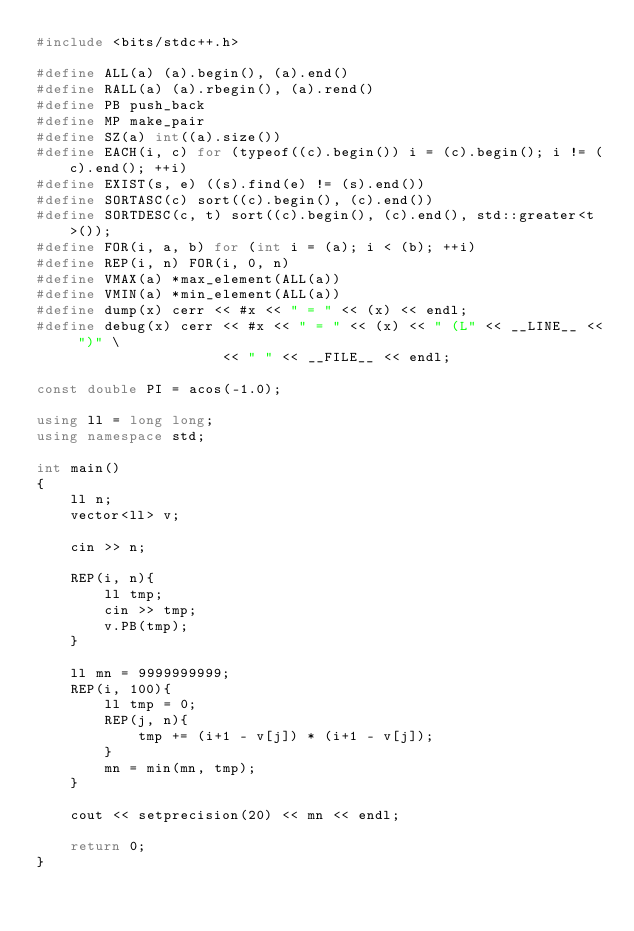Convert code to text. <code><loc_0><loc_0><loc_500><loc_500><_C++_>#include <bits/stdc++.h>

#define ALL(a) (a).begin(), (a).end()
#define RALL(a) (a).rbegin(), (a).rend()
#define PB push_back
#define MP make_pair
#define SZ(a) int((a).size())
#define EACH(i, c) for (typeof((c).begin()) i = (c).begin(); i != (c).end(); ++i)
#define EXIST(s, e) ((s).find(e) != (s).end())
#define SORTASC(c) sort((c).begin(), (c).end())
#define SORTDESC(c, t) sort((c).begin(), (c).end(), std::greater<t>());
#define FOR(i, a, b) for (int i = (a); i < (b); ++i)
#define REP(i, n) FOR(i, 0, n)
#define VMAX(a) *max_element(ALL(a))
#define VMIN(a) *min_element(ALL(a))
#define dump(x) cerr << #x << " = " << (x) << endl;
#define debug(x) cerr << #x << " = " << (x) << " (L" << __LINE__ << ")" \
                      << " " << __FILE__ << endl;

const double PI = acos(-1.0);

using ll = long long;
using namespace std;

int main()
{
    ll n;
    vector<ll> v;

    cin >> n;

    REP(i, n){
        ll tmp;
        cin >> tmp;
        v.PB(tmp);
    }

    ll mn = 9999999999;
    REP(i, 100){
        ll tmp = 0;
        REP(j, n){
            tmp += (i+1 - v[j]) * (i+1 - v[j]);
        }
        mn = min(mn, tmp);
    }

    cout << setprecision(20) << mn << endl;

    return 0;
}</code> 